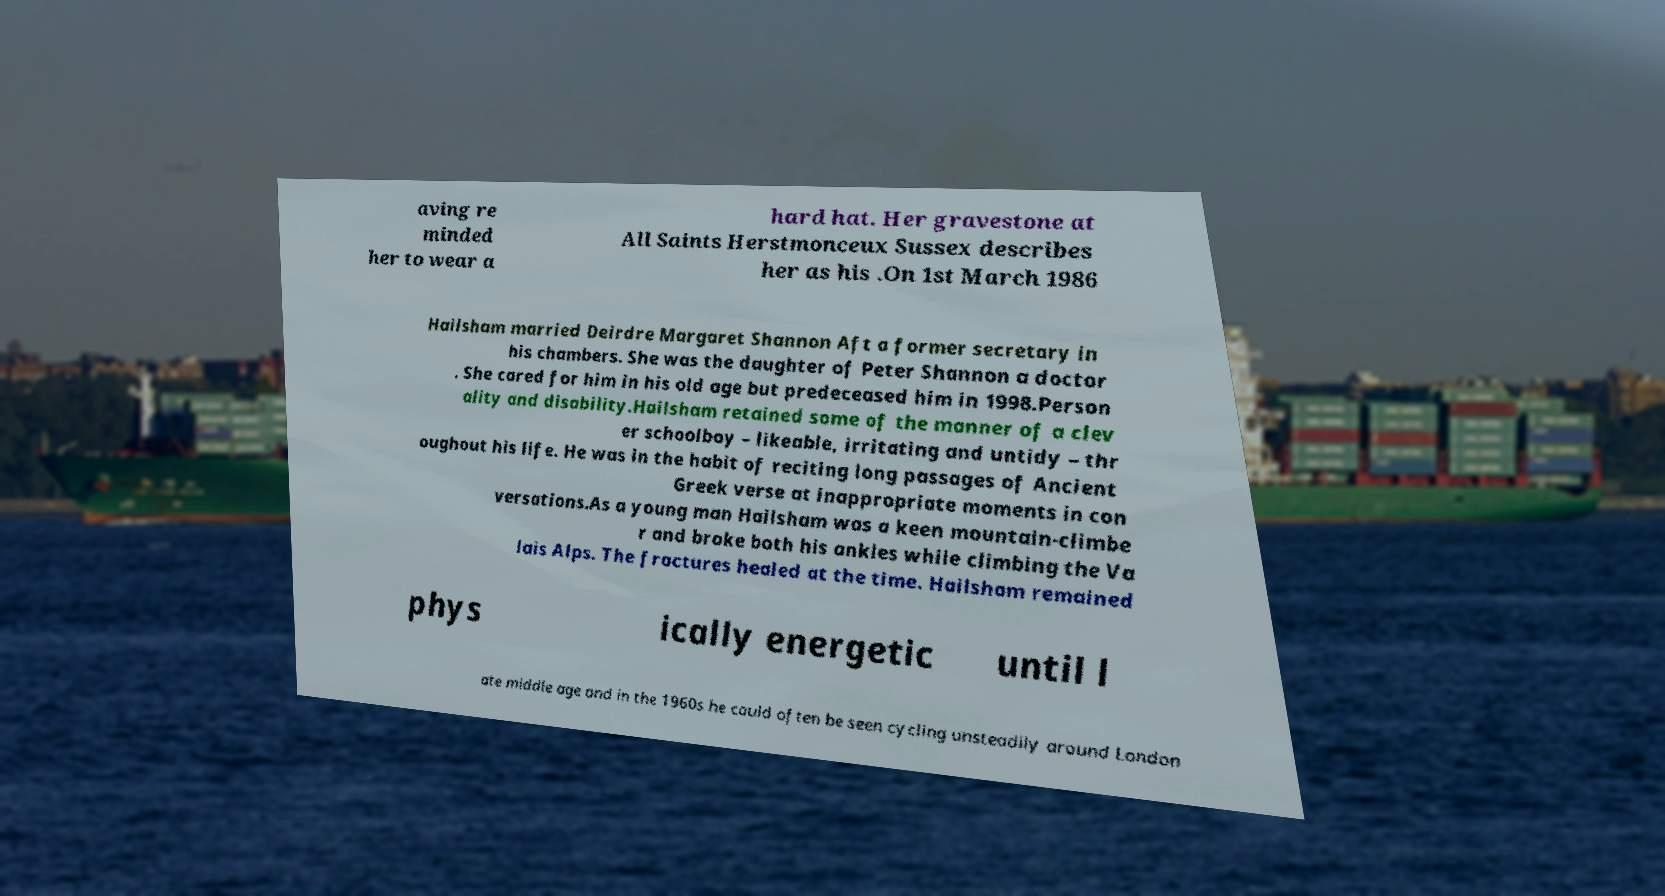Please identify and transcribe the text found in this image. aving re minded her to wear a hard hat. Her gravestone at All Saints Herstmonceux Sussex describes her as his .On 1st March 1986 Hailsham married Deirdre Margaret Shannon Aft a former secretary in his chambers. She was the daughter of Peter Shannon a doctor . She cared for him in his old age but predeceased him in 1998.Person ality and disability.Hailsham retained some of the manner of a clev er schoolboy – likeable, irritating and untidy – thr oughout his life. He was in the habit of reciting long passages of Ancient Greek verse at inappropriate moments in con versations.As a young man Hailsham was a keen mountain-climbe r and broke both his ankles while climbing the Va lais Alps. The fractures healed at the time. Hailsham remained phys ically energetic until l ate middle age and in the 1960s he could often be seen cycling unsteadily around London 